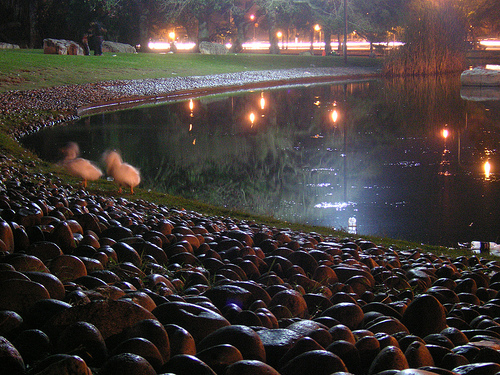<image>
Can you confirm if the duck is in front of the pond? Yes. The duck is positioned in front of the pond, appearing closer to the camera viewpoint. 